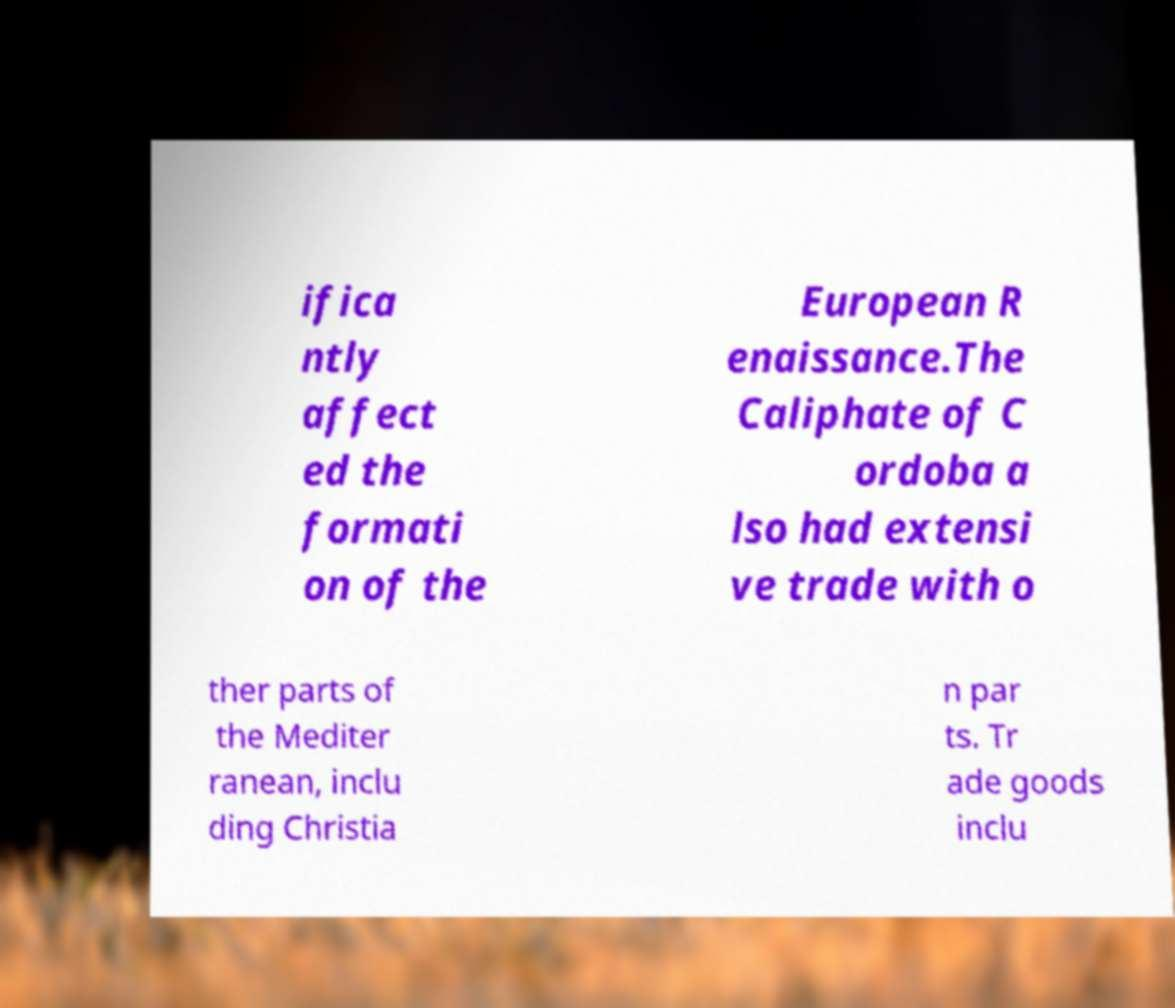There's text embedded in this image that I need extracted. Can you transcribe it verbatim? ifica ntly affect ed the formati on of the European R enaissance.The Caliphate of C ordoba a lso had extensi ve trade with o ther parts of the Mediter ranean, inclu ding Christia n par ts. Tr ade goods inclu 